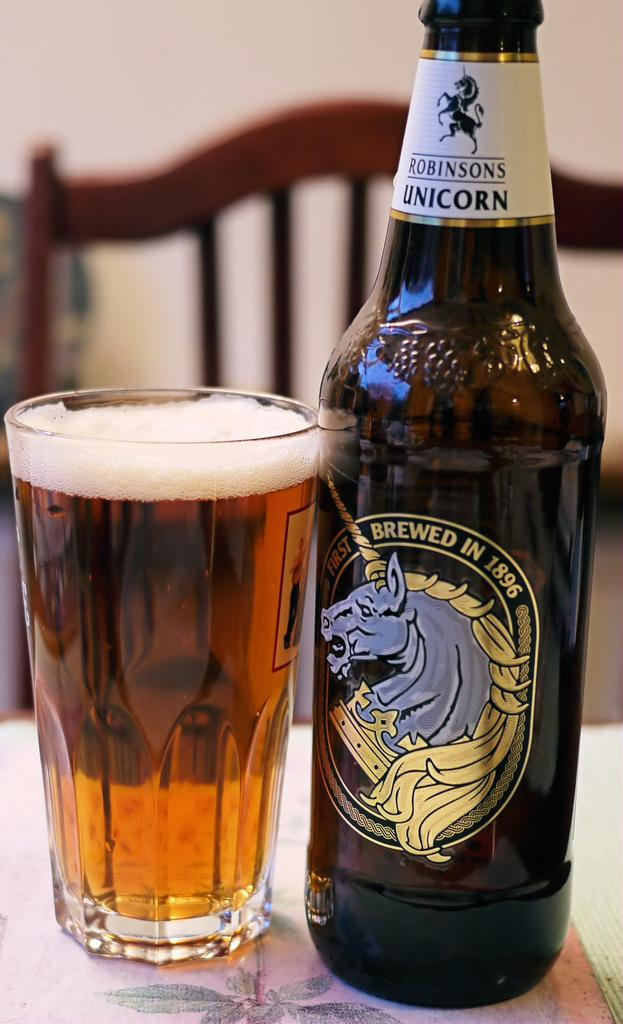<image>
Describe the image concisely. a bottle of robinson's unicorn brewed in 1896 